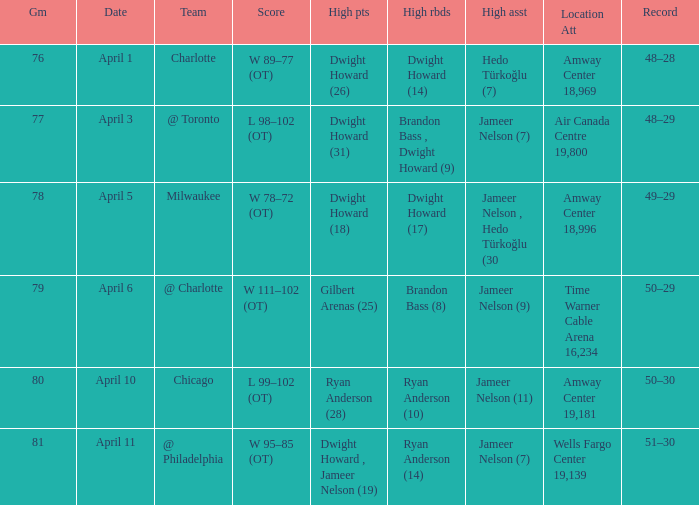Who had the most the most rebounds and how many did they have on April 1? Dwight Howard (14). 